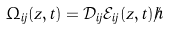<formula> <loc_0><loc_0><loc_500><loc_500>\Omega _ { i j } ( z , t ) = \mathcal { D } _ { i j } \mathcal { E } _ { i j } ( z , t ) / \hbar</formula> 